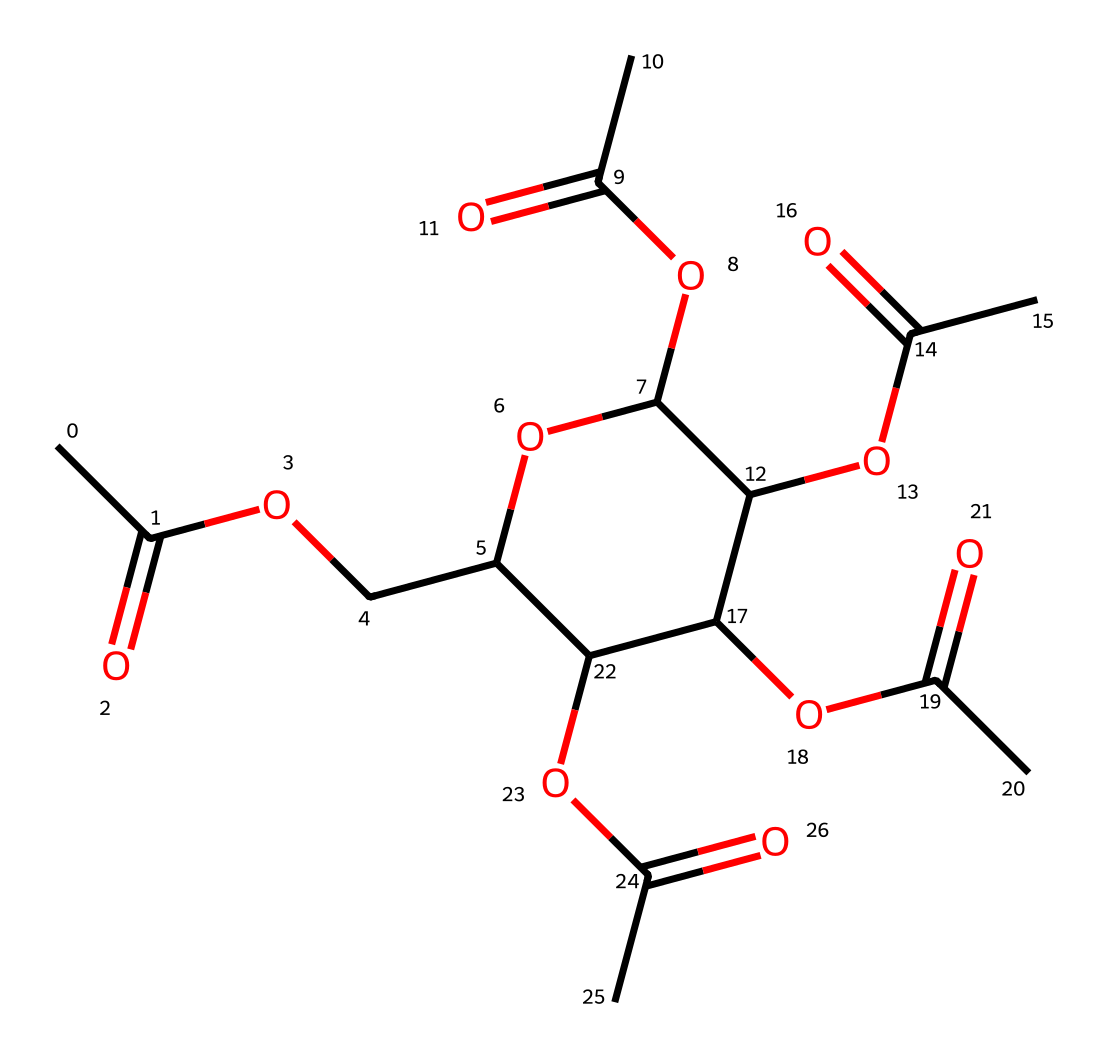What is the molecular formula of cellulose acetate? To determine the molecular formula, we analyze the number of carbon (C), hydrogen (H), and oxygen (O) atoms in the SMILES representation. There are 24 carbon atoms, 38 hydrogen atoms, and 10 oxygen atoms, leading to the molecular formula C24H38O10.
Answer: C24H38O10 How many ester functional groups are present in this compound? By examining the structure, we identify each ester group, characterized by the presence of a carbonyl (C=O) adjacent to an ether (R-O-R) linkage. There are five such groups in the structure.
Answer: 5 What type of polymer is cellulose acetate? Since cellulose acetate is derived from cellulose through a process of acetylation, which replaces hydroxyl groups (-OH) with acetate groups (-OCOCH3), it is classified as a semi-synthetic polymer.
Answer: semi-synthetic polymer What is the primary property that makes cellulose acetate suitable for document preservation? The chemical structure of cellulose acetate contributes to its biodegradability and resistance to environmental factors such as moisture and air, making it ideal for preserving documents.
Answer: biodegradability How many cyclic ether rings are present in cellulose acetate? The analysis of the structure reveals that there are four cyclic ether rings due to the presence of the 1,3-dioxane units linked to the cellulose backbone.
Answer: 4 